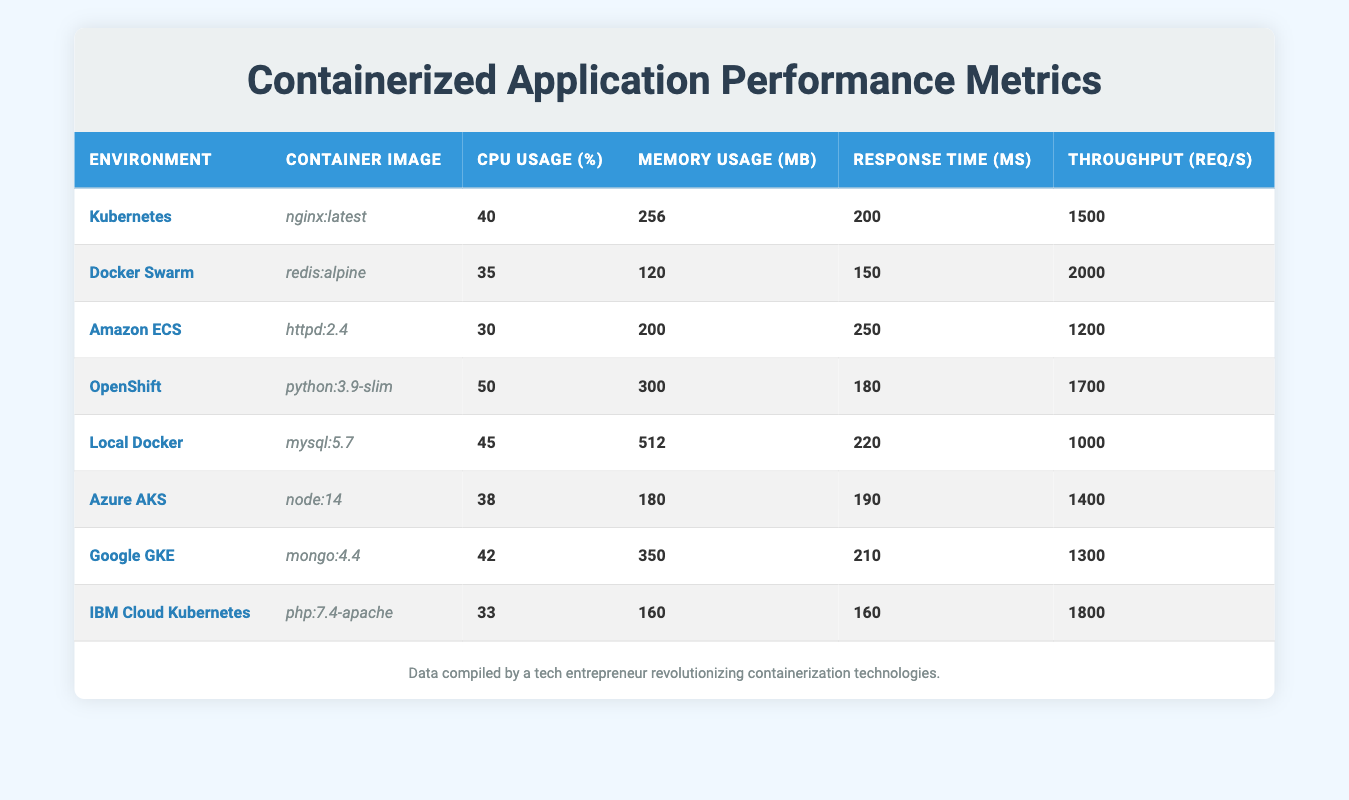What is the CPU usage percent of the Kubernetes environment? The table states that the CPU usage percent for the Kubernetes environment is listed directly in the corresponding row under the "CPU Usage (%)" column, which shows a value of 40.
Answer: 40 Which container image has the highest memory usage in megabytes? By examining the "Memory Usage (MB)" column of the table, we can see the following values: 256, 120, 200, 300, 512, 180, 350, 160. The highest value among these is 512, which corresponds to the "Local Docker" environment.
Answer: Local Docker What is the average response time in milliseconds across all environments? To calculate the average response time, I sum all the response times: (200 + 150 + 250 + 180 + 220 + 190 + 210 + 160) = 1360. There are 8 environments, so the average is 1360 / 8 = 170.
Answer: 170 Is the throughput for the Docker Swarm environment greater than the throughput for the Amazon ECS environment? In the table, the throughput for Docker Swarm is 2000 requests per second, while for Amazon ECS it is 1200 requests per second. Since 2000 is greater than 1200, the answer is yes.
Answer: Yes What is the difference in CPU usage percent between the OpenShift and IBM Cloud Kubernetes environments? For OpenShift, the CPU usage percent is 50, and for IBM Cloud Kubernetes, it is 33. The difference is calculated as 50 - 33 = 17.
Answer: 17 Which environment has the lowest response time, and what is that time? By checking the "Response Time (ms)" column, we compare the times: 200, 150, 250, 180, 220, 190, 210, 160. The lowest time is 150, which corresponds to Docker Swarm.
Answer: Docker Swarm, 150 How many environments have a throughput greater than 1500 requests per second? Reviewing the "Throughput (req/s)" column, we identify these values: 1500, 2000, 1200, 1700, 1000, 1400, 1300, 1800. Only Docker Swarm (2000), OpenShift (1700), and IBM Cloud Kubernetes (1800) exceed 1500. Thus, there are 3 environments.
Answer: 3 Is the memory usage of the Google GKE environment less than that of the Local Docker environment? The memory usage for Google GKE is 350 MB, while for Local Docker it is 512 MB. Since 350 is less than 512, the answer is yes.
Answer: Yes 